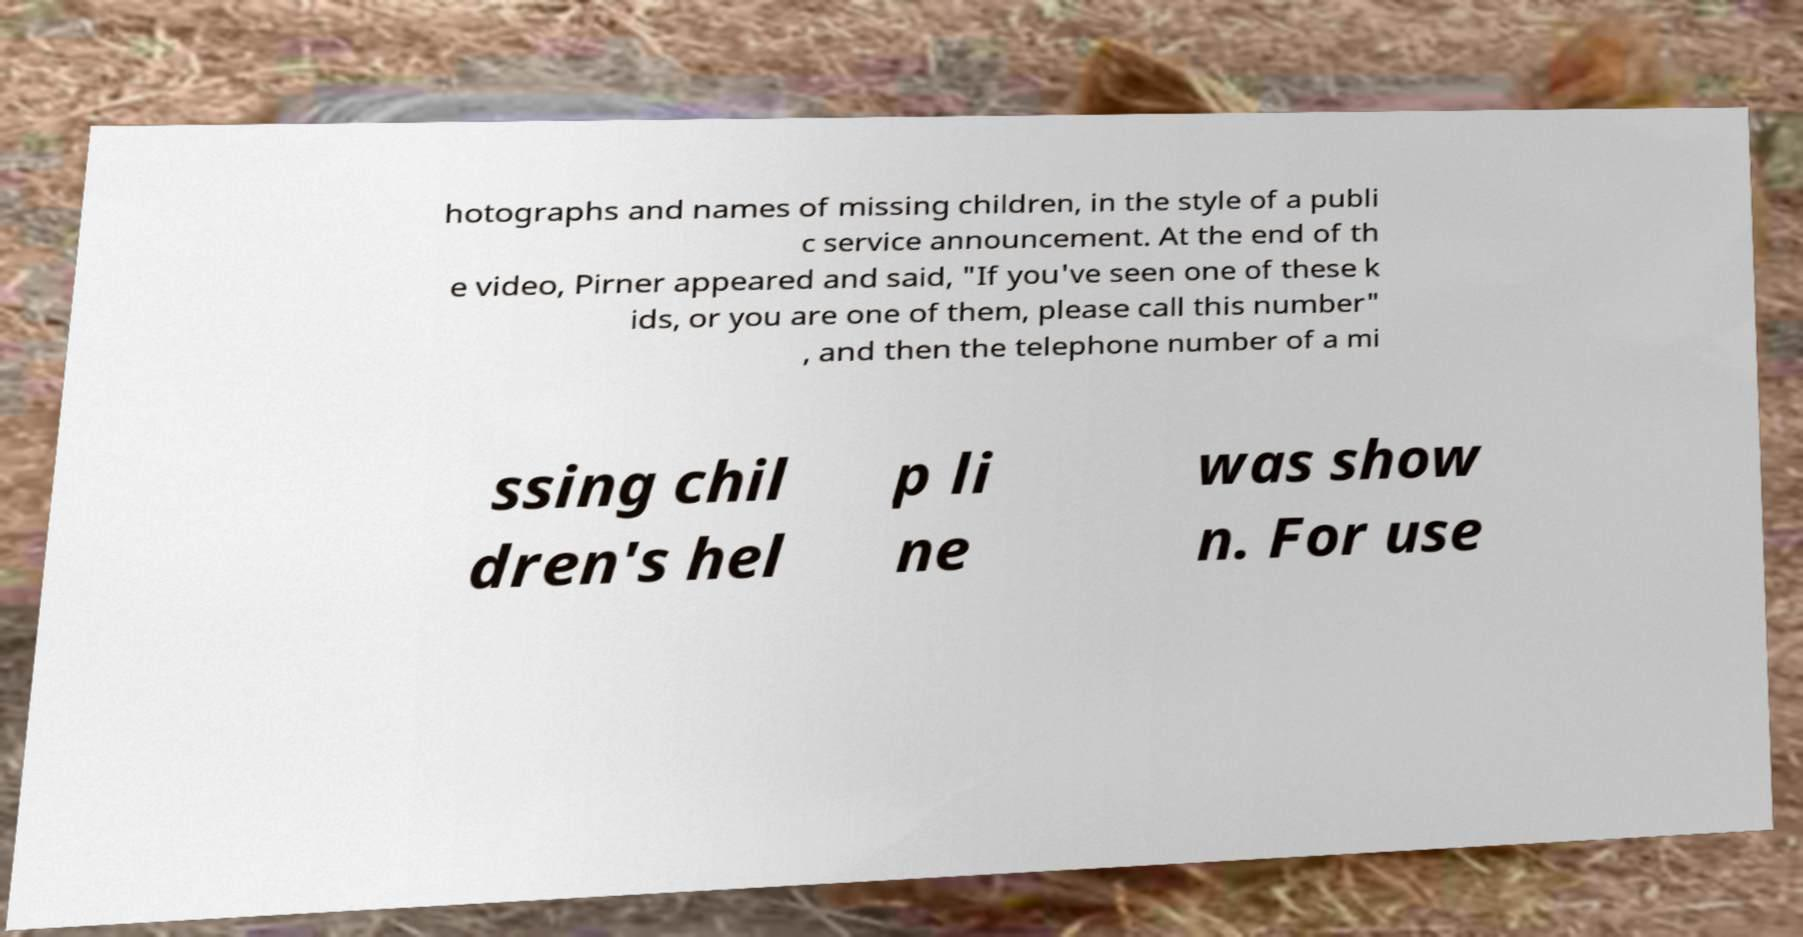For documentation purposes, I need the text within this image transcribed. Could you provide that? hotographs and names of missing children, in the style of a publi c service announcement. At the end of th e video, Pirner appeared and said, "If you've seen one of these k ids, or you are one of them, please call this number" , and then the telephone number of a mi ssing chil dren's hel p li ne was show n. For use 